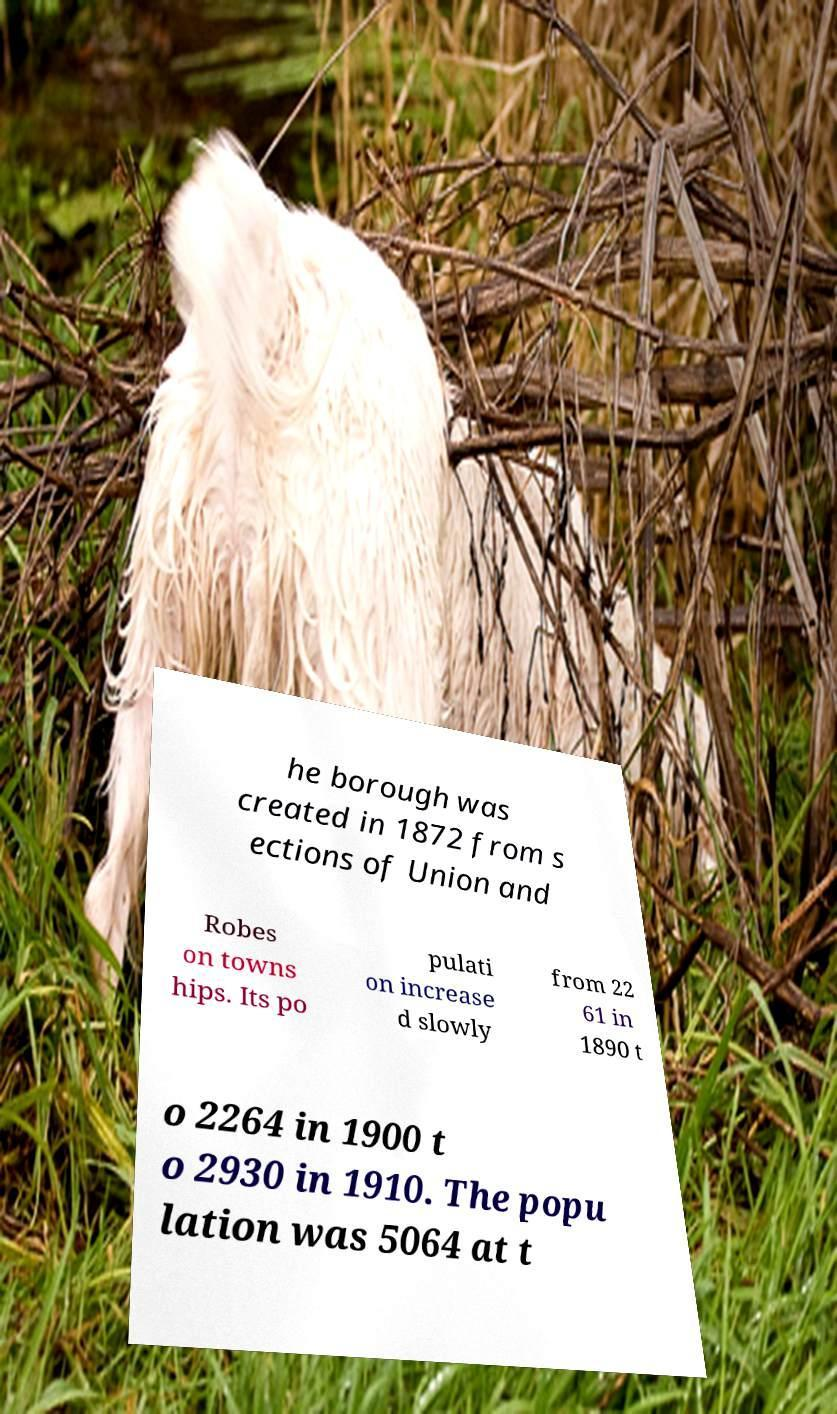What messages or text are displayed in this image? I need them in a readable, typed format. he borough was created in 1872 from s ections of Union and Robes on towns hips. Its po pulati on increase d slowly from 22 61 in 1890 t o 2264 in 1900 t o 2930 in 1910. The popu lation was 5064 at t 